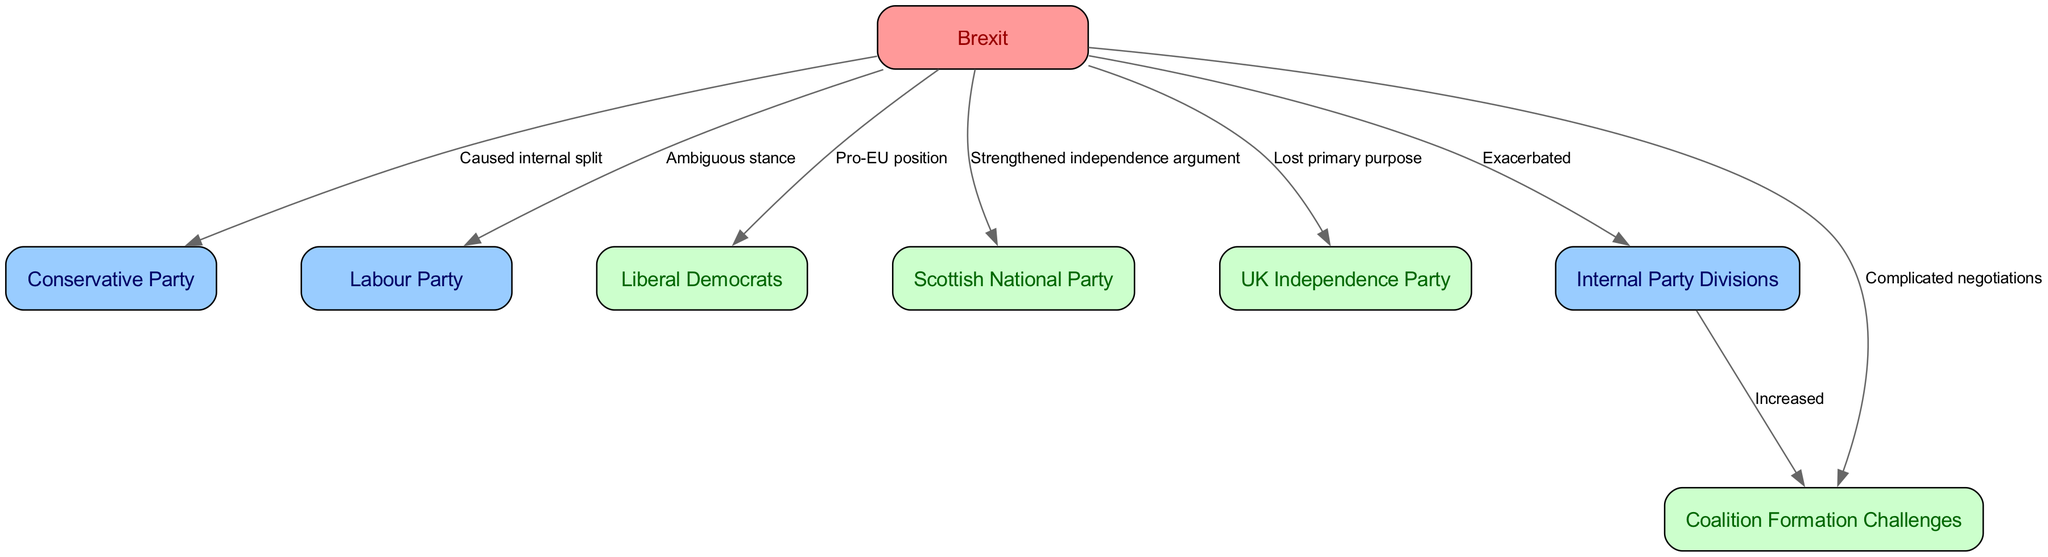What node is at the center of the diagram? The central node is "Brexit," as all other nodes connect to it to show its impact on various political parties and coalition dynamics.
Answer: Brexit How many political parties are represented in the diagram? There are five political parties represented: Conservative Party, Labour Party, Liberal Democrats, SNP, and UKIP.
Answer: 5 What relationship does Brexit have with the UK Independence Party? Brexit caused the UK Independence Party to lose its primary purpose, indicating a negative impact on its significance following the referendum.
Answer: Lost primary purpose What do internal party divisions lead to in the context of this diagram? Internal party divisions increase coalition challenges, suggesting that disagreements within parties complicate the formation of coalitions.
Answer: Increased Which political party has a pro-EU stance according to the diagram? The Liberal Democrats are indicated as having a pro-EU position, which contrasts with other parties' stances on Brexit.
Answer: Liberal Democrats What is a consequence of Brexit on the Conservative Party? Brexit caused an internal split within the Conservative Party, highlighting significant divisions resulting from differing Brexit opinions.
Answer: Caused internal split How does Brexit complicate coalition negotiations? The diagram indicates that Brexit complicates negotiations by creating complex issues stemming from party divisions and varying party positions.
Answer: Complicated negotiations Which party argues for independence as a result of Brexit? The Scottish National Party (SNP) is shown to have strengthened its independence argument due to the Brexit situation.
Answer: Strengthened independence argument What effect has Brexit had on party divisions? Brexit has exacerbated internal party divisions, which indicates an increase in conflicts and disagreements among party members.
Answer: Exacerbated 